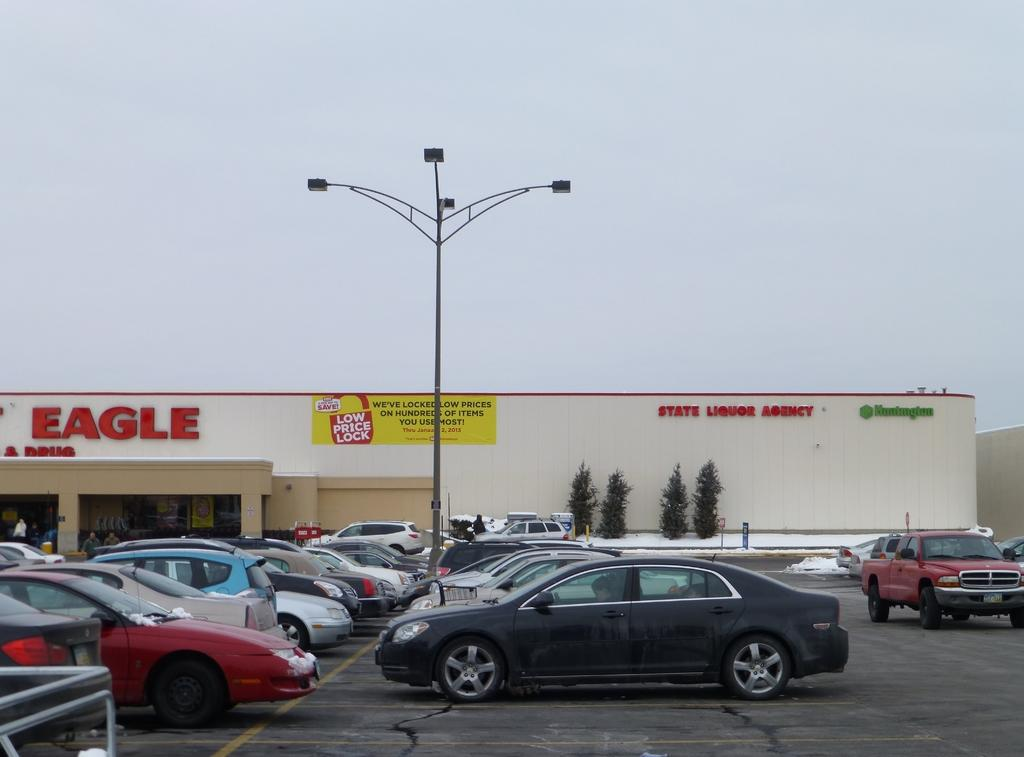What can be seen in the parking lot in the image? There is a group of cars parked in the parking lot. What is visible in the background of the image? There are four trees, a light pole, a building with sign boards, and the sky visible in the background. Are any of the cars wearing masks in the image? There are no masks present on the cars in the image, as cars do not have the ability to wear masks. 